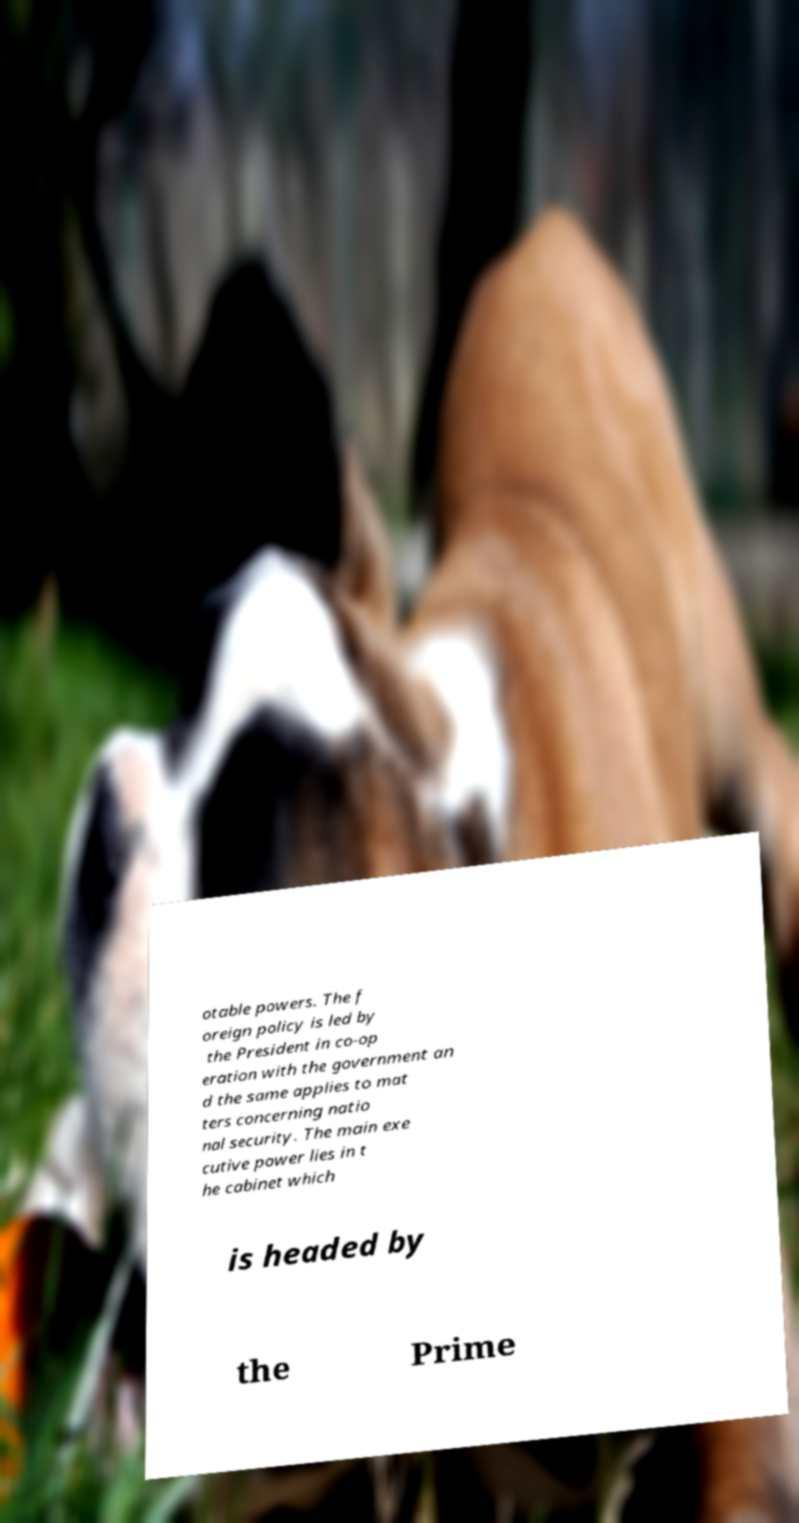Can you read and provide the text displayed in the image?This photo seems to have some interesting text. Can you extract and type it out for me? otable powers. The f oreign policy is led by the President in co-op eration with the government an d the same applies to mat ters concerning natio nal security. The main exe cutive power lies in t he cabinet which is headed by the Prime 